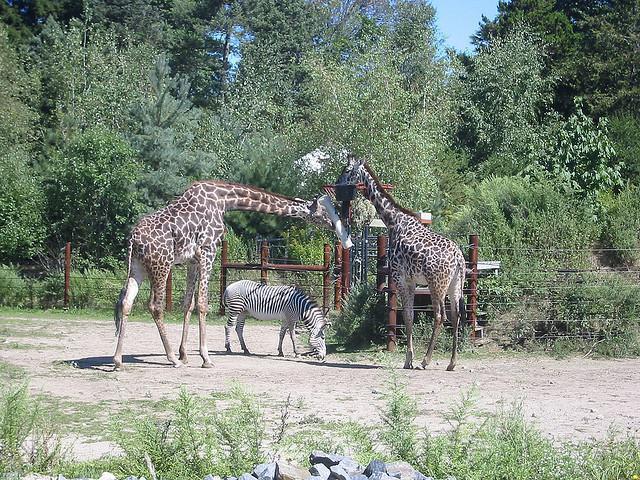What animal is between the giraffes?
Choose the right answer from the provided options to respond to the question.
Options: Goose, cow, zebra, salamander. Zebra. What animal is between the giraffes?
Select the correct answer and articulate reasoning with the following format: 'Answer: answer
Rationale: rationale.'
Options: Cat, zebra, cow, dog. Answer: zebra.
Rationale: The animal has black and white stripes. 